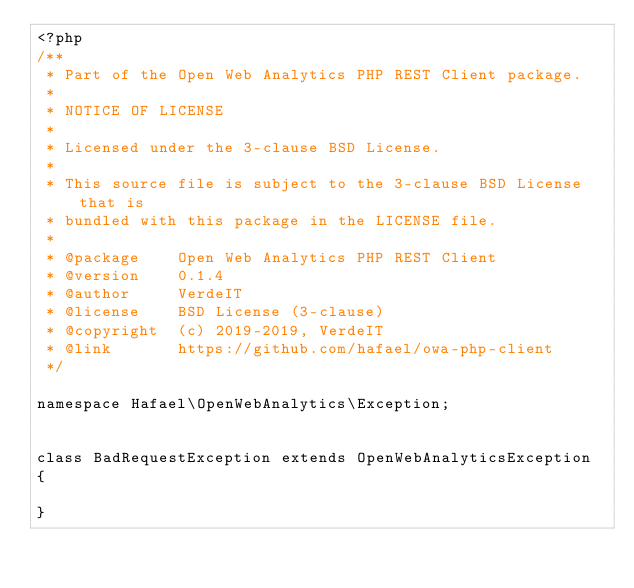Convert code to text. <code><loc_0><loc_0><loc_500><loc_500><_PHP_><?php
/**
 * Part of the Open Web Analytics PHP REST Client package.
 *
 * NOTICE OF LICENSE
 *
 * Licensed under the 3-clause BSD License.
 *
 * This source file is subject to the 3-clause BSD License that is
 * bundled with this package in the LICENSE file.
 *
 * @package    Open Web Analytics PHP REST Client
 * @version    0.1.4
 * @author     VerdeIT
 * @license    BSD License (3-clause)
 * @copyright  (c) 2019-2019, VerdeIT
 * @link       https://github.com/hafael/owa-php-client
 */

namespace Hafael\OpenWebAnalytics\Exception;


class BadRequestException extends OpenWebAnalyticsException
{

}</code> 